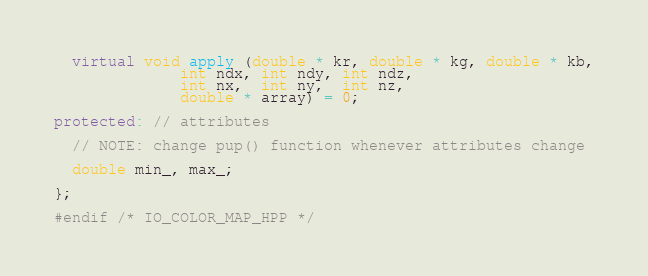<code> <loc_0><loc_0><loc_500><loc_500><_C++_>  virtual void apply (double * kr, double * kg, double * kb,
		      int ndx, int ndy, int ndz,
		      int nx,  int ny,  int nz,
		      double * array) = 0;

protected: // attributes

  // NOTE: change pup() function whenever attributes change

  double min_, max_;

};

#endif /* IO_COLOR_MAP_HPP */

</code> 